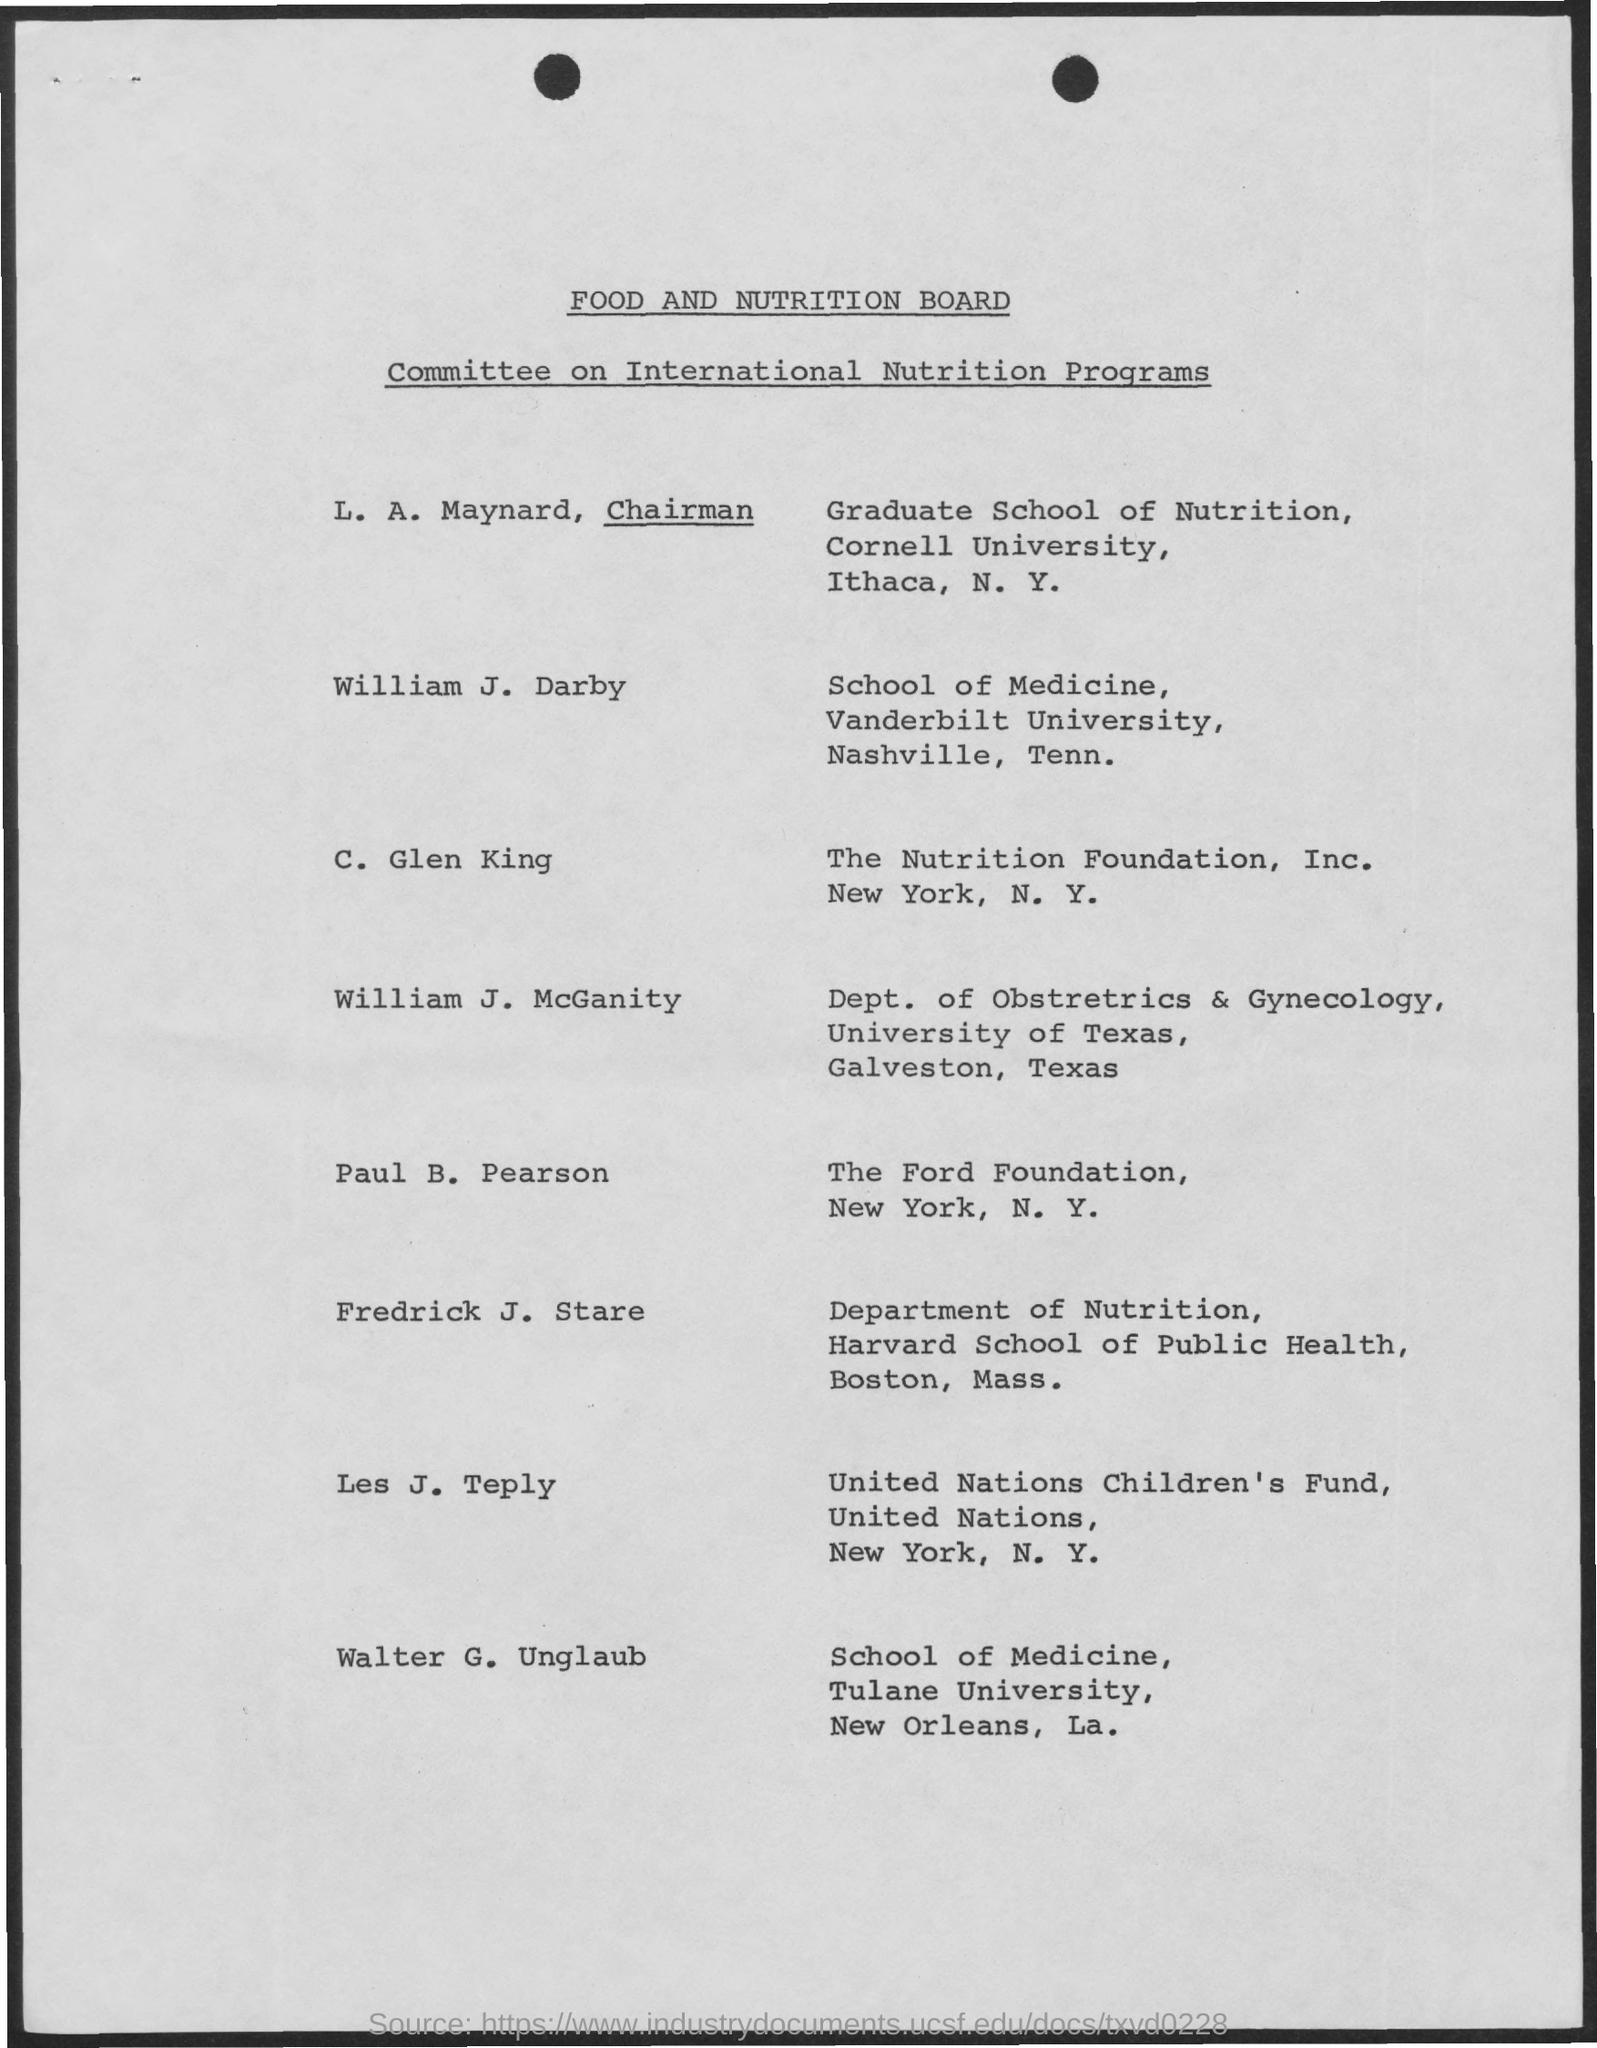Indicate a few pertinent items in this graphic. The chairman is LA Maynard. 